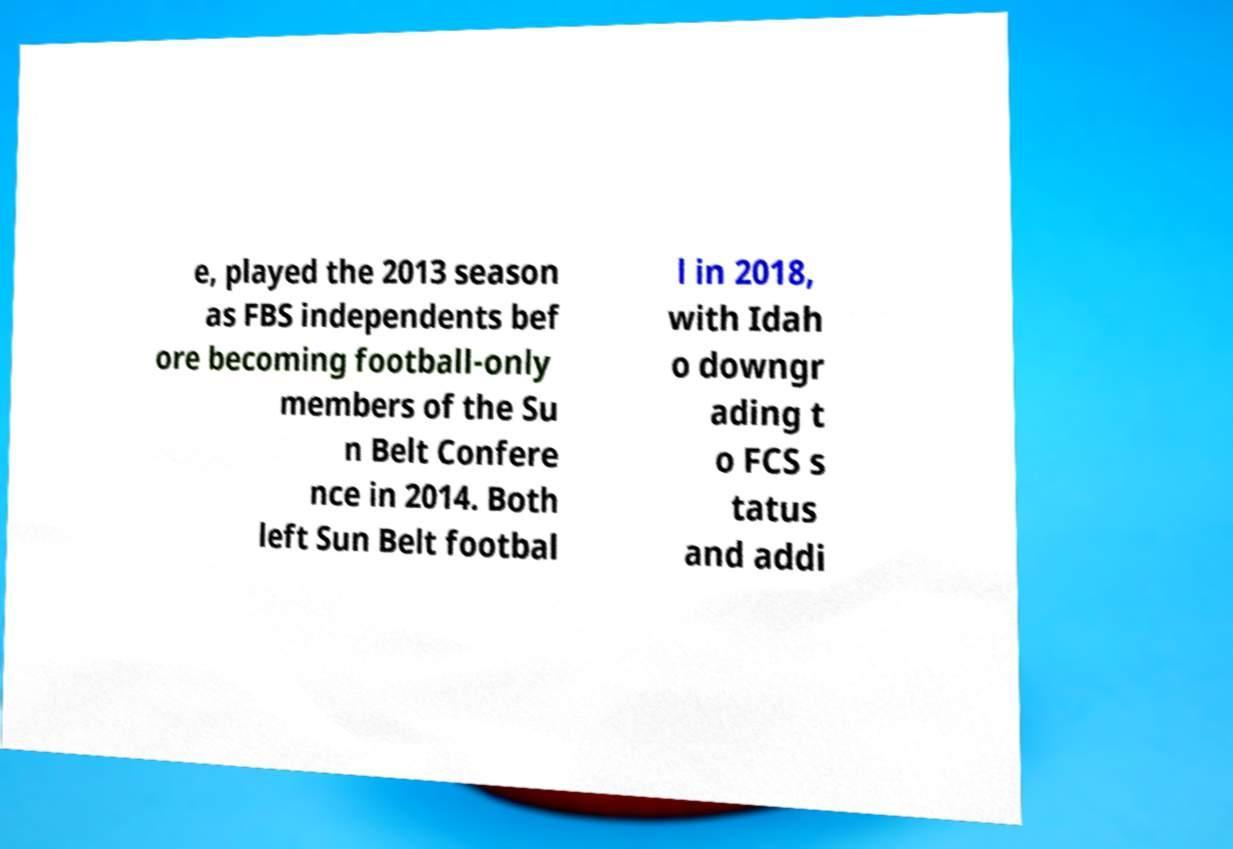There's text embedded in this image that I need extracted. Can you transcribe it verbatim? e, played the 2013 season as FBS independents bef ore becoming football-only members of the Su n Belt Confere nce in 2014. Both left Sun Belt footbal l in 2018, with Idah o downgr ading t o FCS s tatus and addi 